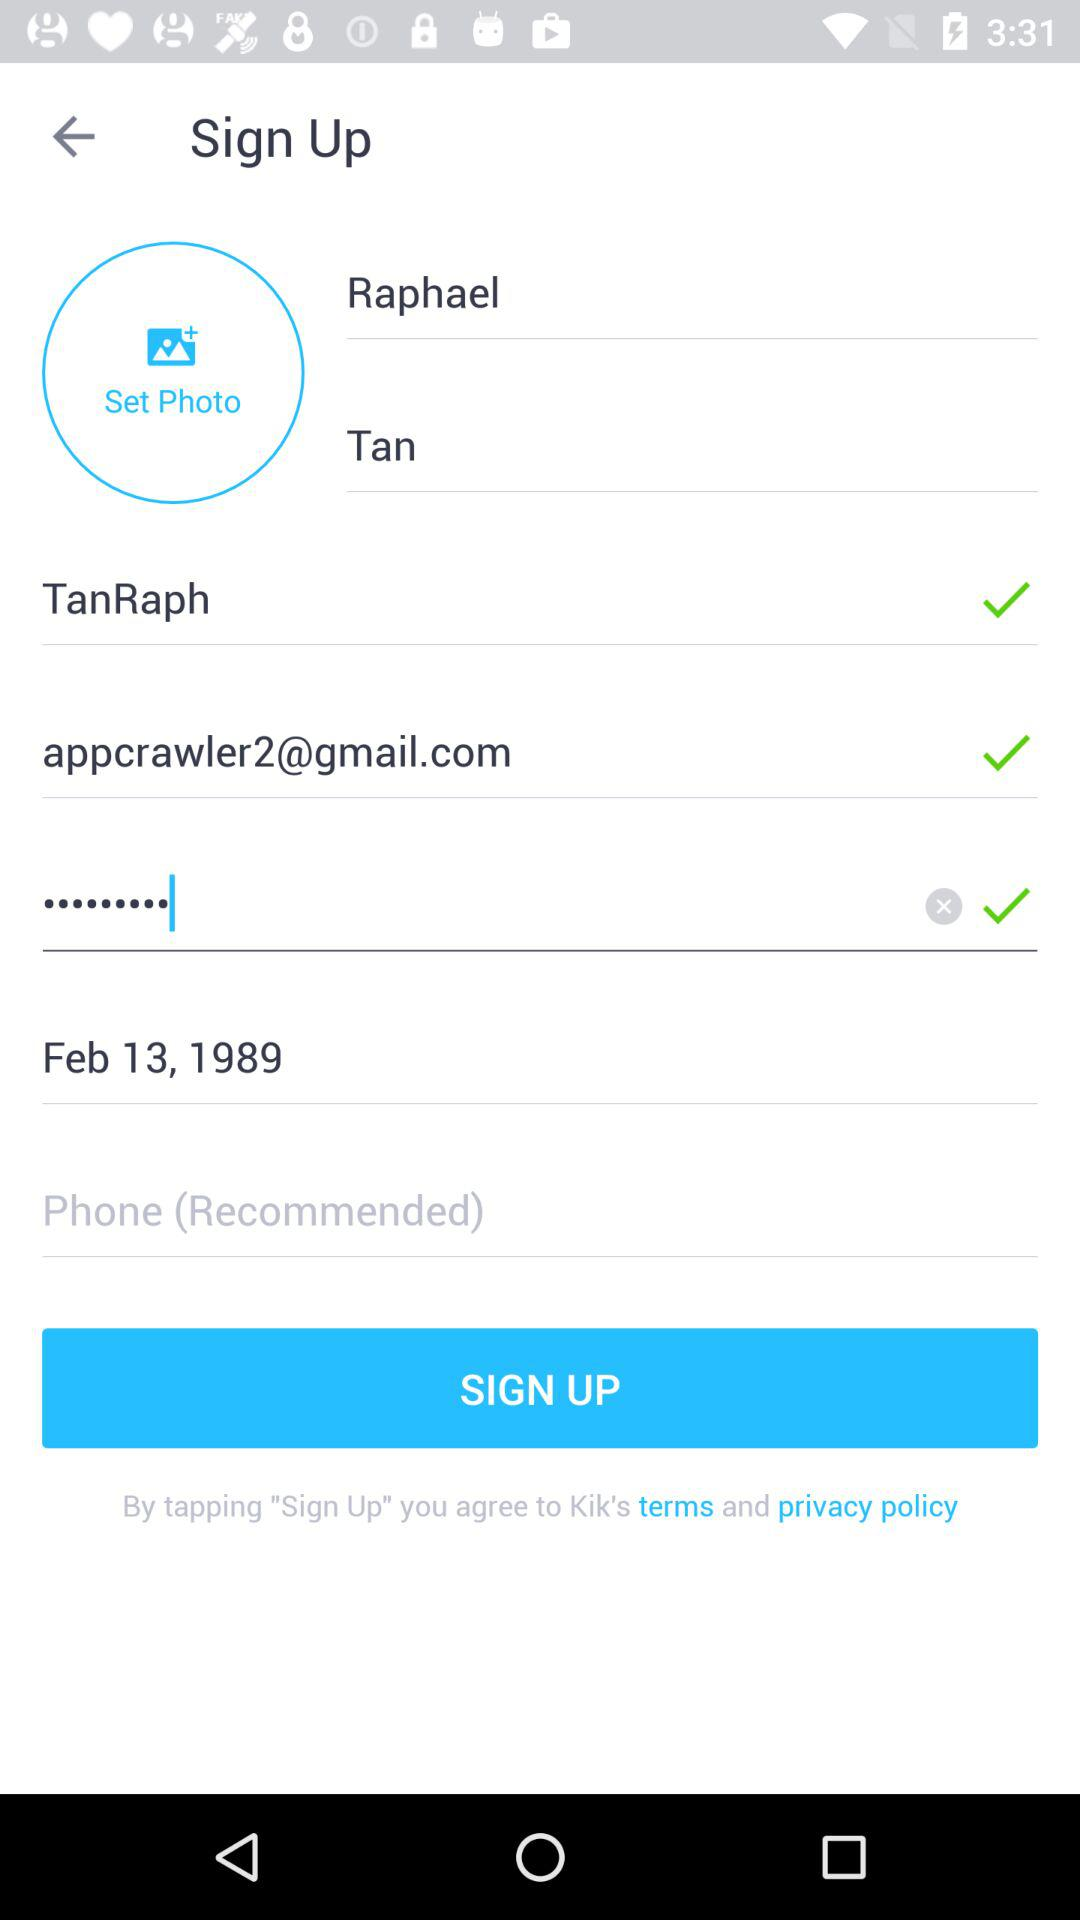What is the birth date? The birth date is February 13, 1989. 